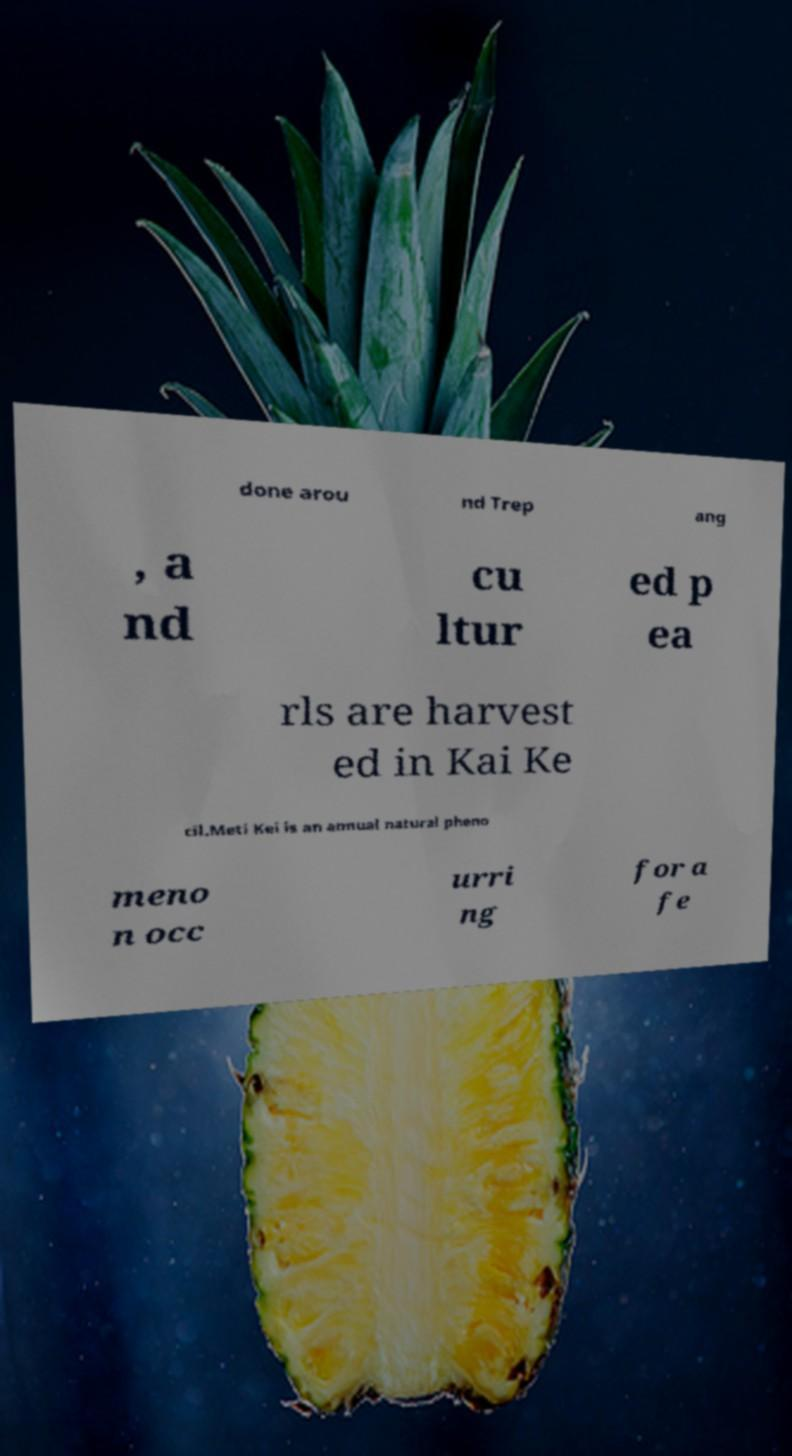Could you assist in decoding the text presented in this image and type it out clearly? done arou nd Trep ang , a nd cu ltur ed p ea rls are harvest ed in Kai Ke cil.Meti Kei is an annual natural pheno meno n occ urri ng for a fe 